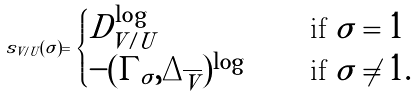<formula> <loc_0><loc_0><loc_500><loc_500>s _ { V / U } ( \sigma ) = \begin{cases} D ^ { \log } _ { V / U } & \quad \text { if } \sigma = 1 \\ - ( \Gamma _ { \sigma } , \Delta _ { \overline { V } } ) ^ { \log } & \quad \text { if } \sigma \neq 1 . \end{cases}</formula> 